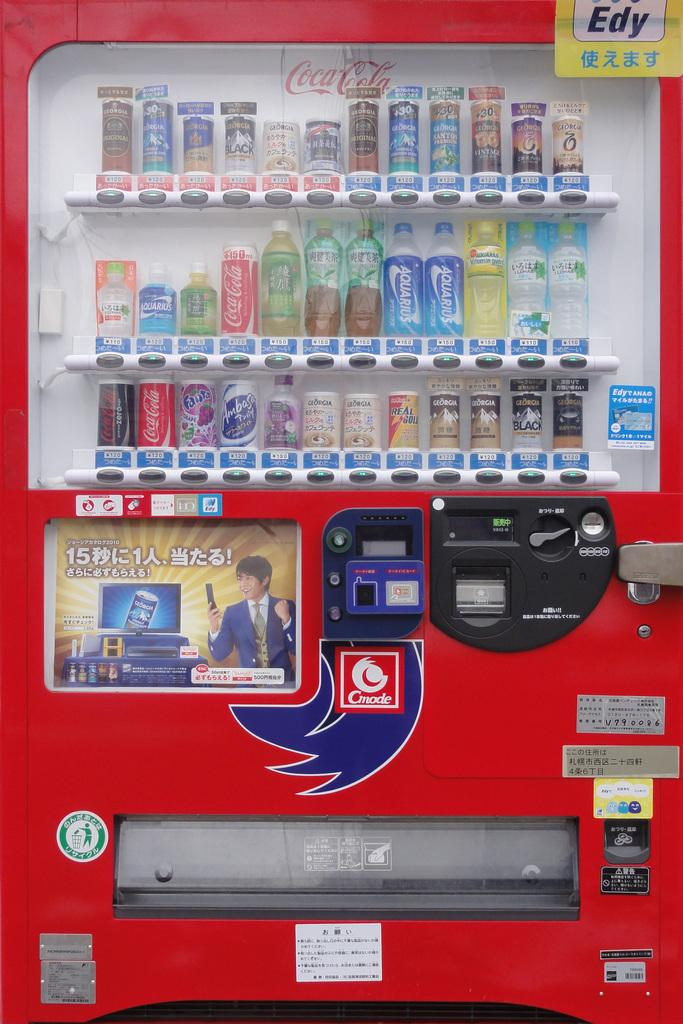Provide a one-sentence caption for the provided image. a machine that has drinks in it that says 'coca-cola' in the back. 